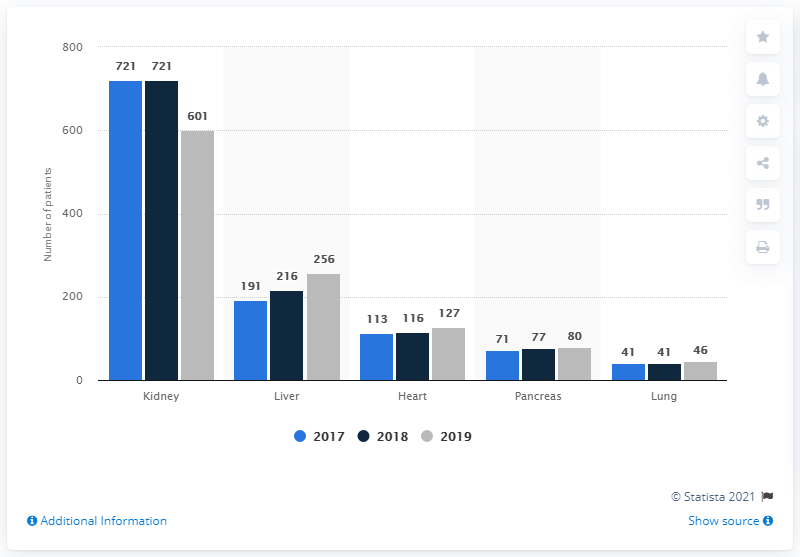Point out several critical features in this image. There was a 65% increase in the number of patients who were active on the Liver transplant waiting list in Belarus between 2015 and 2017. There were 721 active patients on the kidney transplant waiting list in Belarus in 2015. 